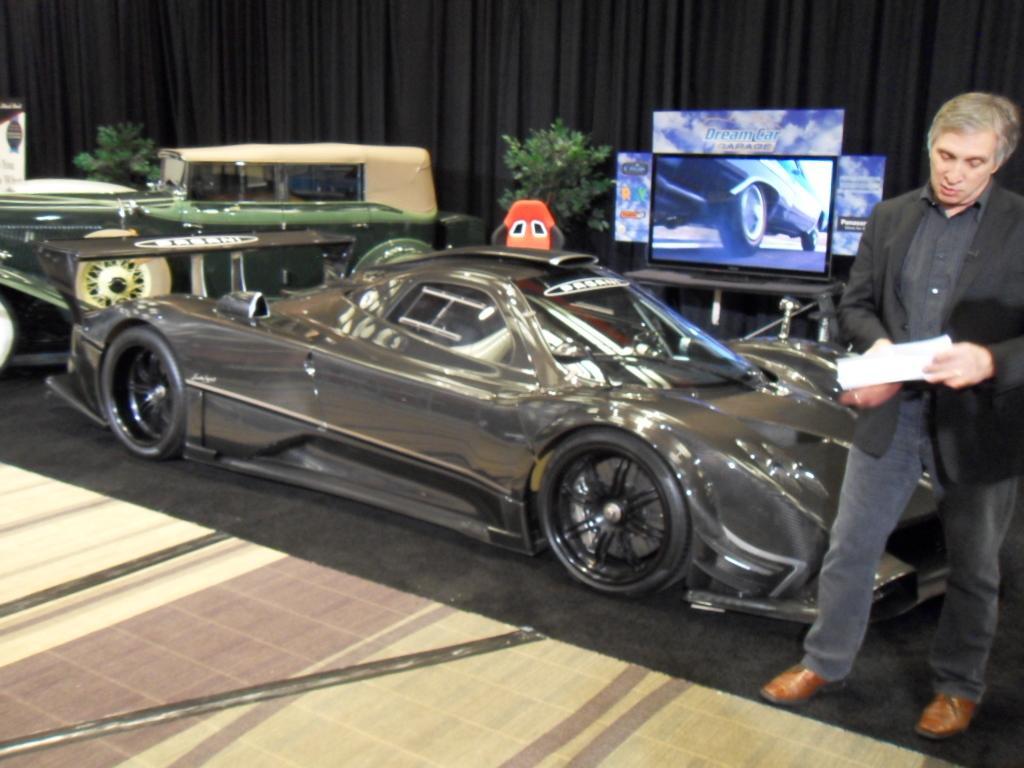Can you describe this image briefly? In the image we can see a man standing, he is wearing clothes and shoes, and the man is holding a paper in his hand. This is a screen, plant, curtains black in color and carpet. There are even vehicles. 